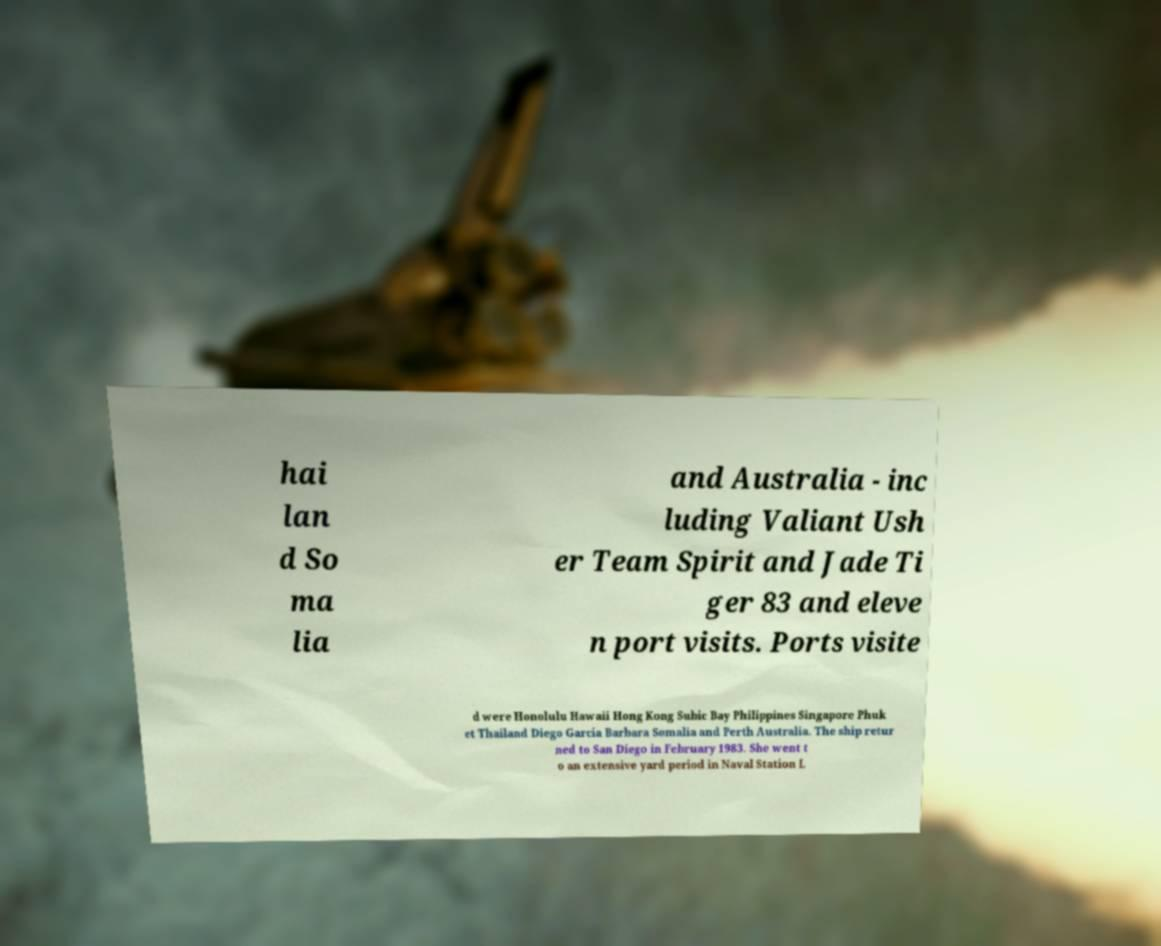Can you read and provide the text displayed in the image?This photo seems to have some interesting text. Can you extract and type it out for me? hai lan d So ma lia and Australia - inc luding Valiant Ush er Team Spirit and Jade Ti ger 83 and eleve n port visits. Ports visite d were Honolulu Hawaii Hong Kong Subic Bay Philippines Singapore Phuk et Thailand Diego Garcia Barbara Somalia and Perth Australia. The ship retur ned to San Diego in February 1983. She went t o an extensive yard period in Naval Station L 